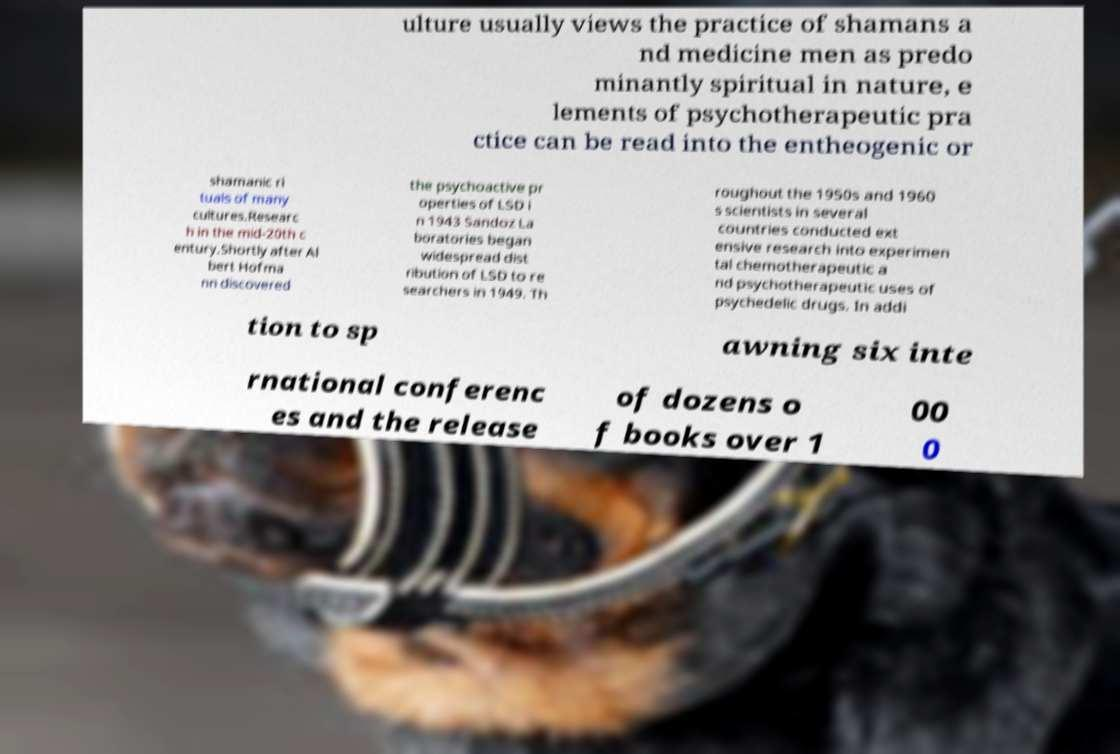There's text embedded in this image that I need extracted. Can you transcribe it verbatim? ulture usually views the practice of shamans a nd medicine men as predo minantly spiritual in nature, e lements of psychotherapeutic pra ctice can be read into the entheogenic or shamanic ri tuals of many cultures.Researc h in the mid-20th c entury.Shortly after Al bert Hofma nn discovered the psychoactive pr operties of LSD i n 1943 Sandoz La boratories began widespread dist ribution of LSD to re searchers in 1949. Th roughout the 1950s and 1960 s scientists in several countries conducted ext ensive research into experimen tal chemotherapeutic a nd psychotherapeutic uses of psychedelic drugs. In addi tion to sp awning six inte rnational conferenc es and the release of dozens o f books over 1 00 0 